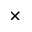<formula> <loc_0><loc_0><loc_500><loc_500>\times</formula> 